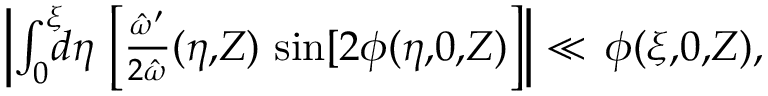Convert formula to latex. <formula><loc_0><loc_0><loc_500><loc_500>\begin{array} { r } { \left | \int _ { 0 } ^ { \xi } \, d \eta \, \left [ \frac { \hat { \omega } ^ { \prime } } { 2 \hat { \omega } } ( \eta , \, Z ) \, \sin [ 2 \phi ( \eta , \, 0 , \, Z ) \right ] \right | \ll \, \phi ( \xi , \, 0 , \, Z ) , } \end{array}</formula> 